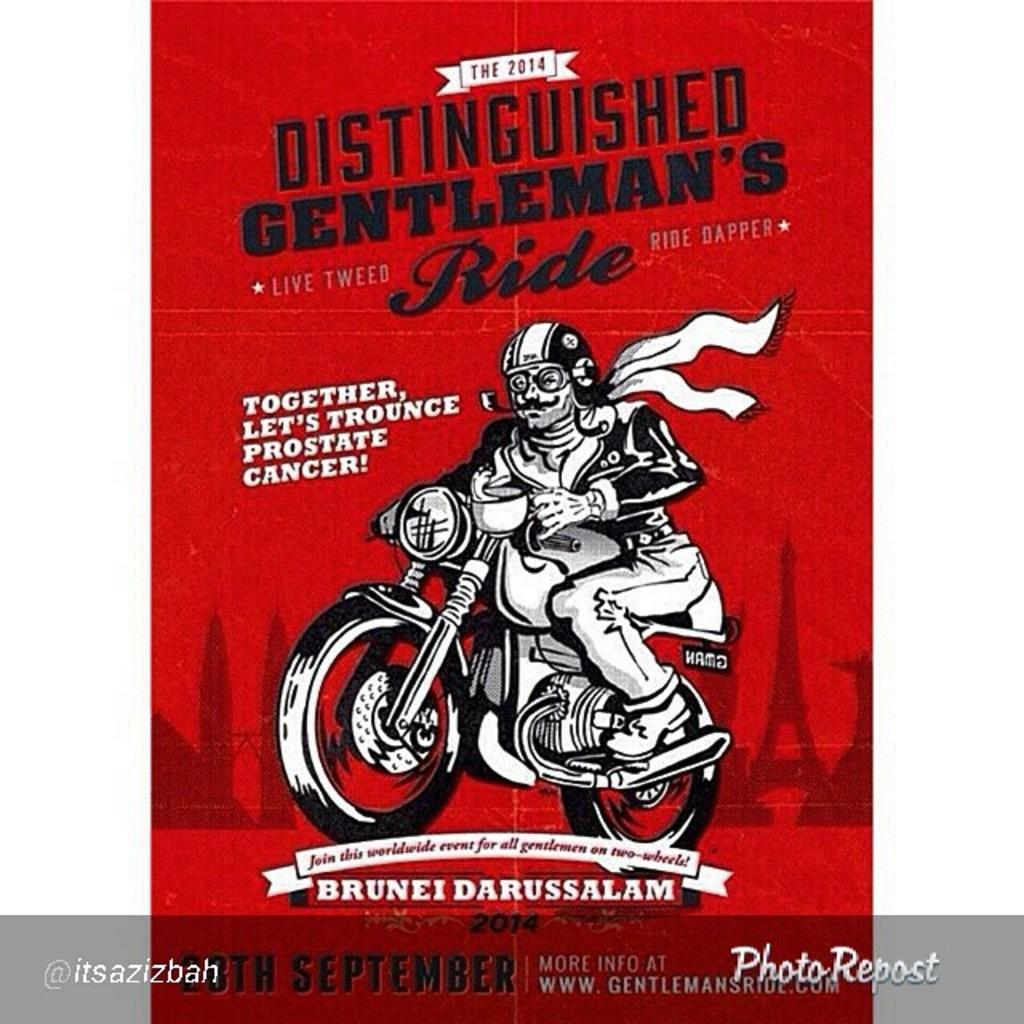What is the main subject of the poster in the image? The main subject of the poster in the image is a man riding a bike. What color is the background of the man in the poster? The background of the man is in red color. Is there any text on the poster? Yes, there is some text on the red color background. Can you tell me how many threads are used to create the man's shirt in the image? There is no information about the man's shirt or threads in the image, as it only shows a poster with a picture of a man riding a bike. 